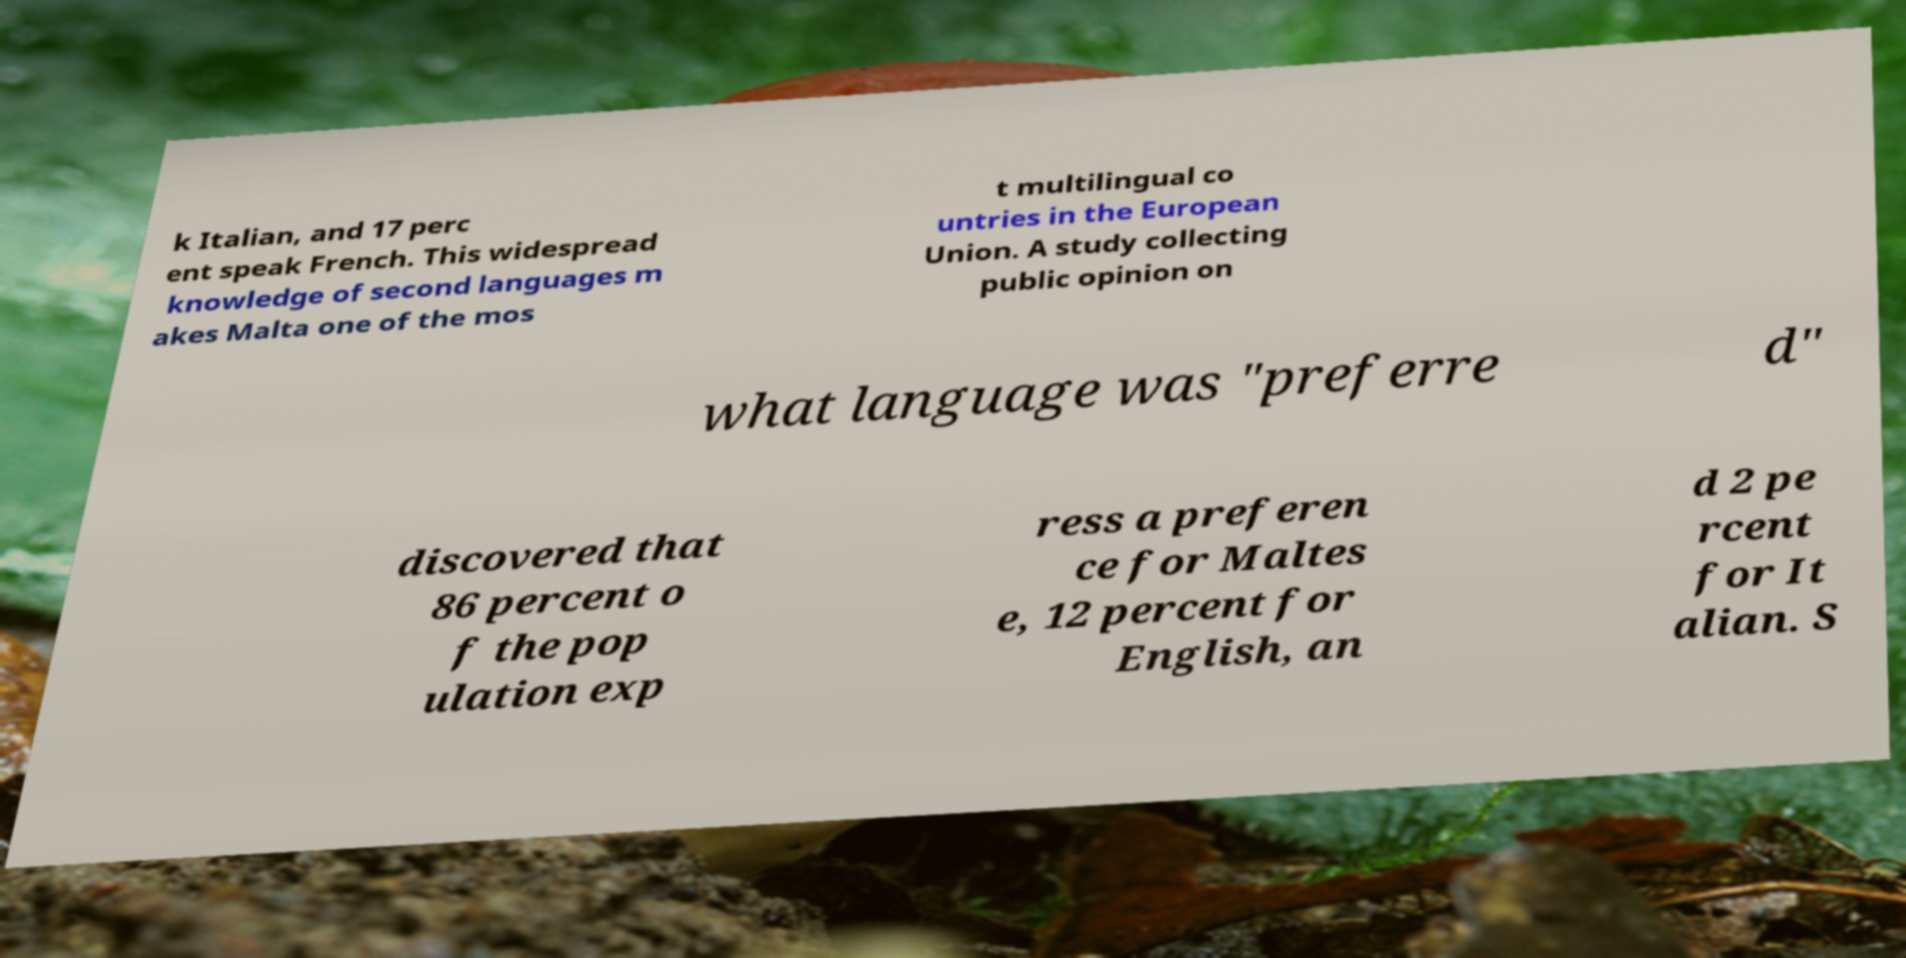For documentation purposes, I need the text within this image transcribed. Could you provide that? k Italian, and 17 perc ent speak French. This widespread knowledge of second languages m akes Malta one of the mos t multilingual co untries in the European Union. A study collecting public opinion on what language was "preferre d" discovered that 86 percent o f the pop ulation exp ress a preferen ce for Maltes e, 12 percent for English, an d 2 pe rcent for It alian. S 